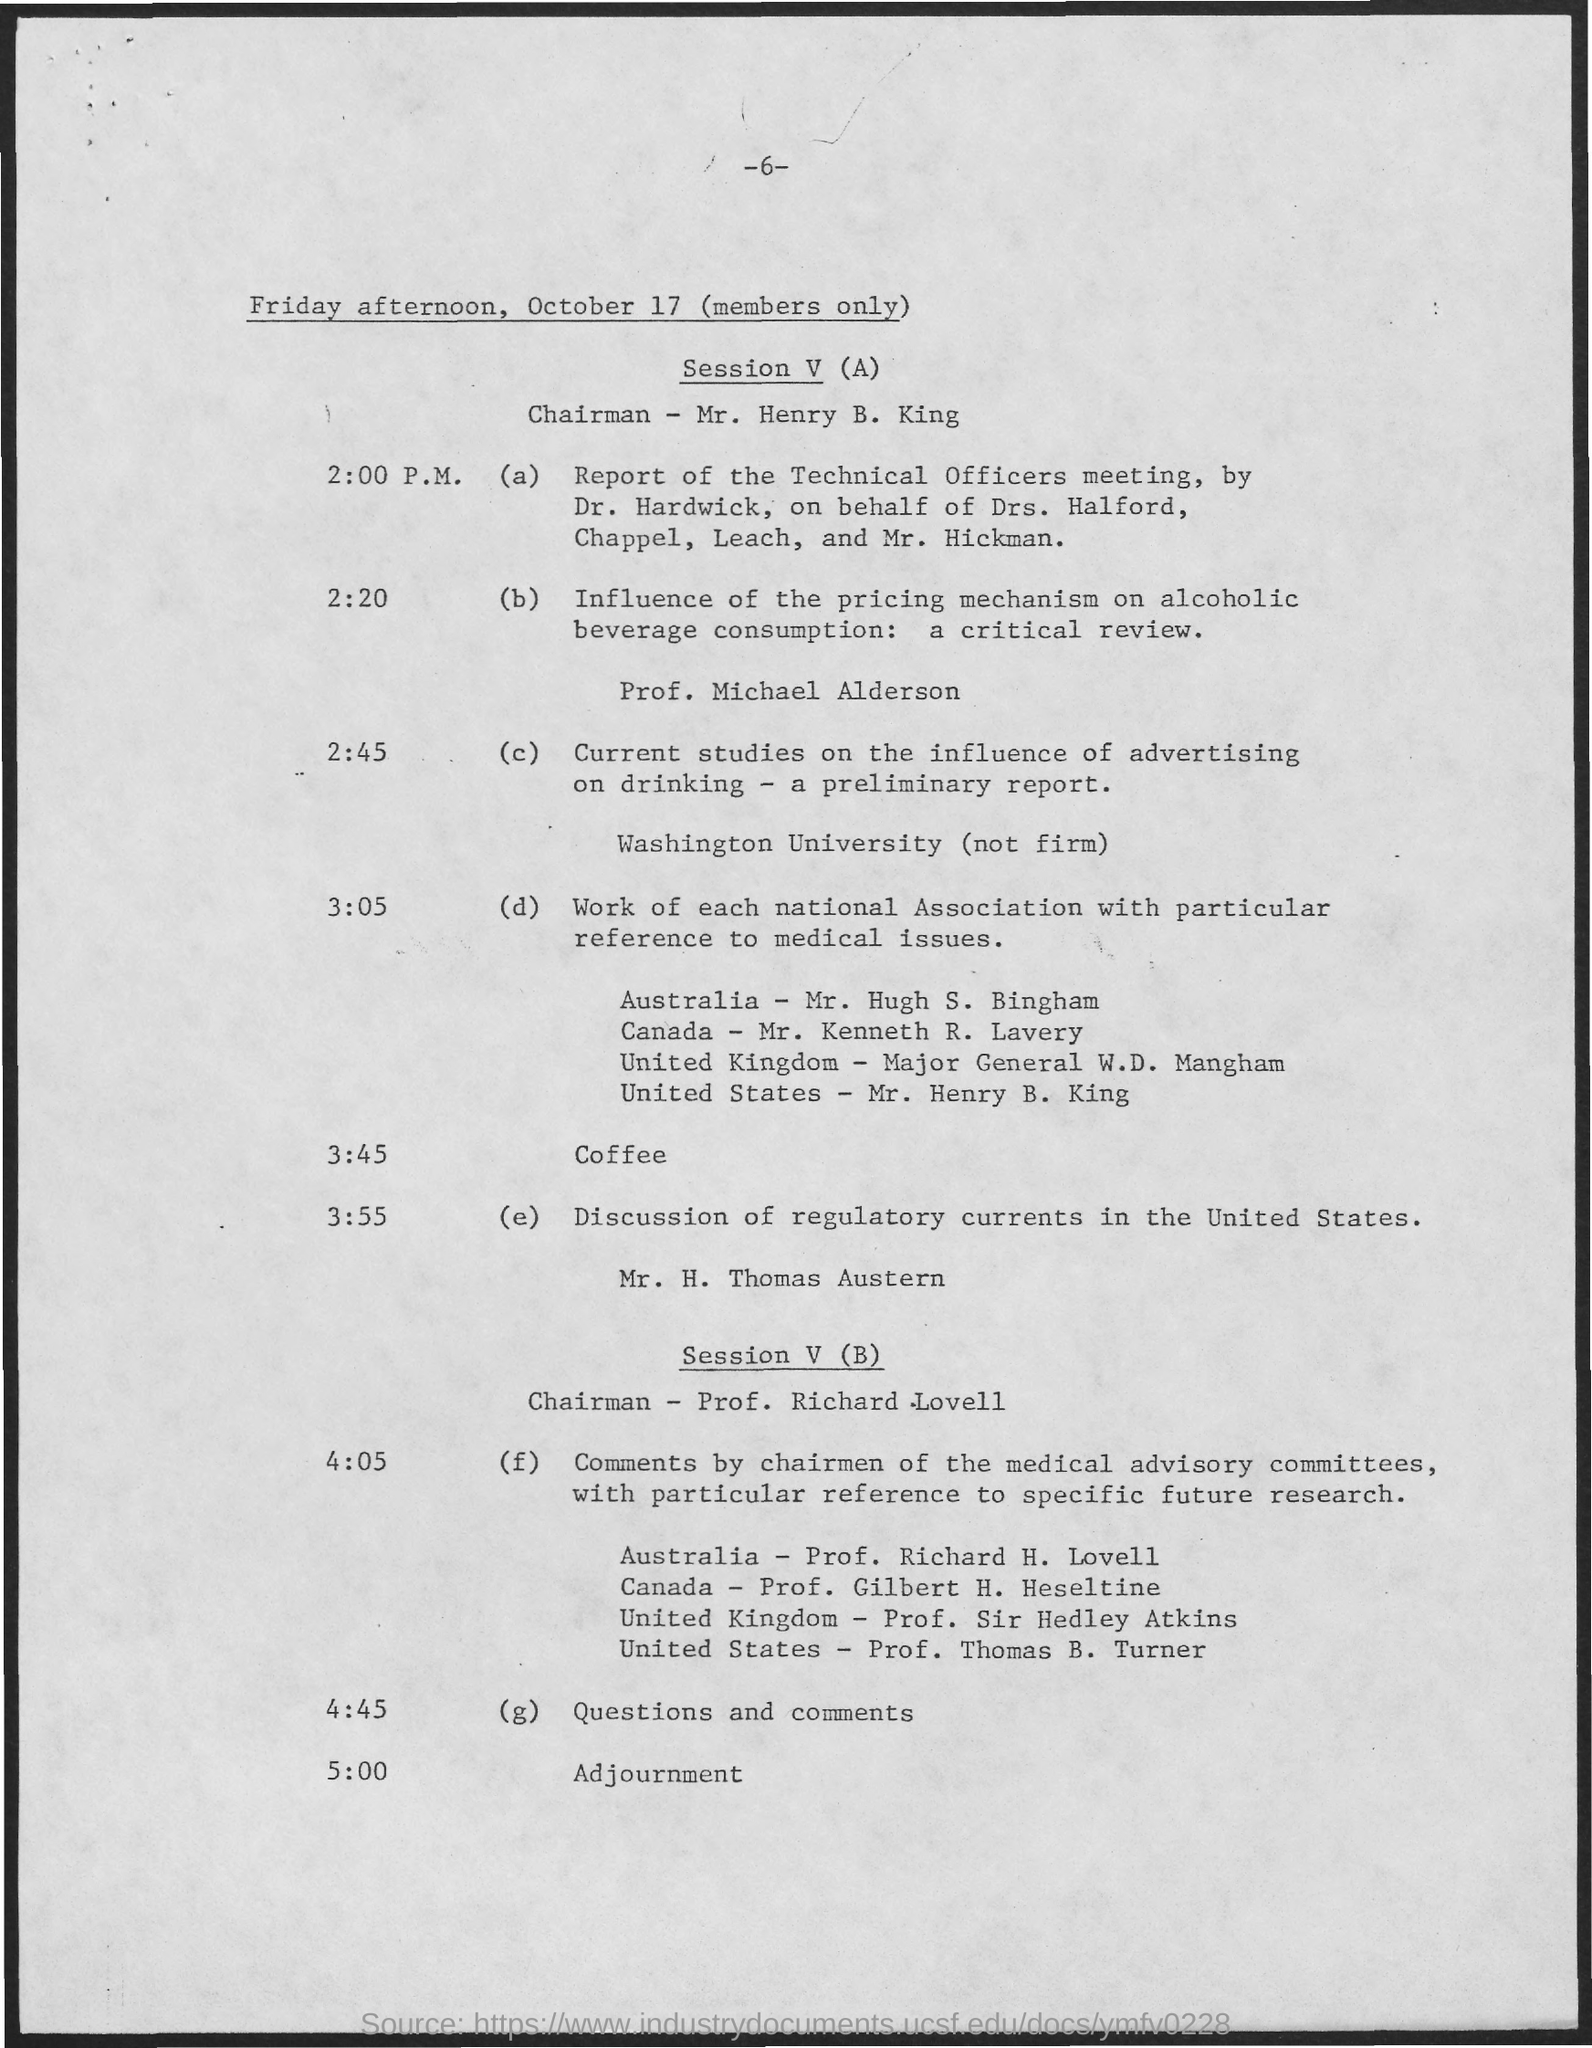What is the page number on this document?
Your answer should be very brief. - 6 -. Who is the chairman for Session V (A) on October 17?
Ensure brevity in your answer.  Mr. Henry B. King. What is the program at 3:55?
Offer a terse response. Discussion of regulatory currents in the United States. What is the event at 5:00?
Ensure brevity in your answer.  Adjournment. 